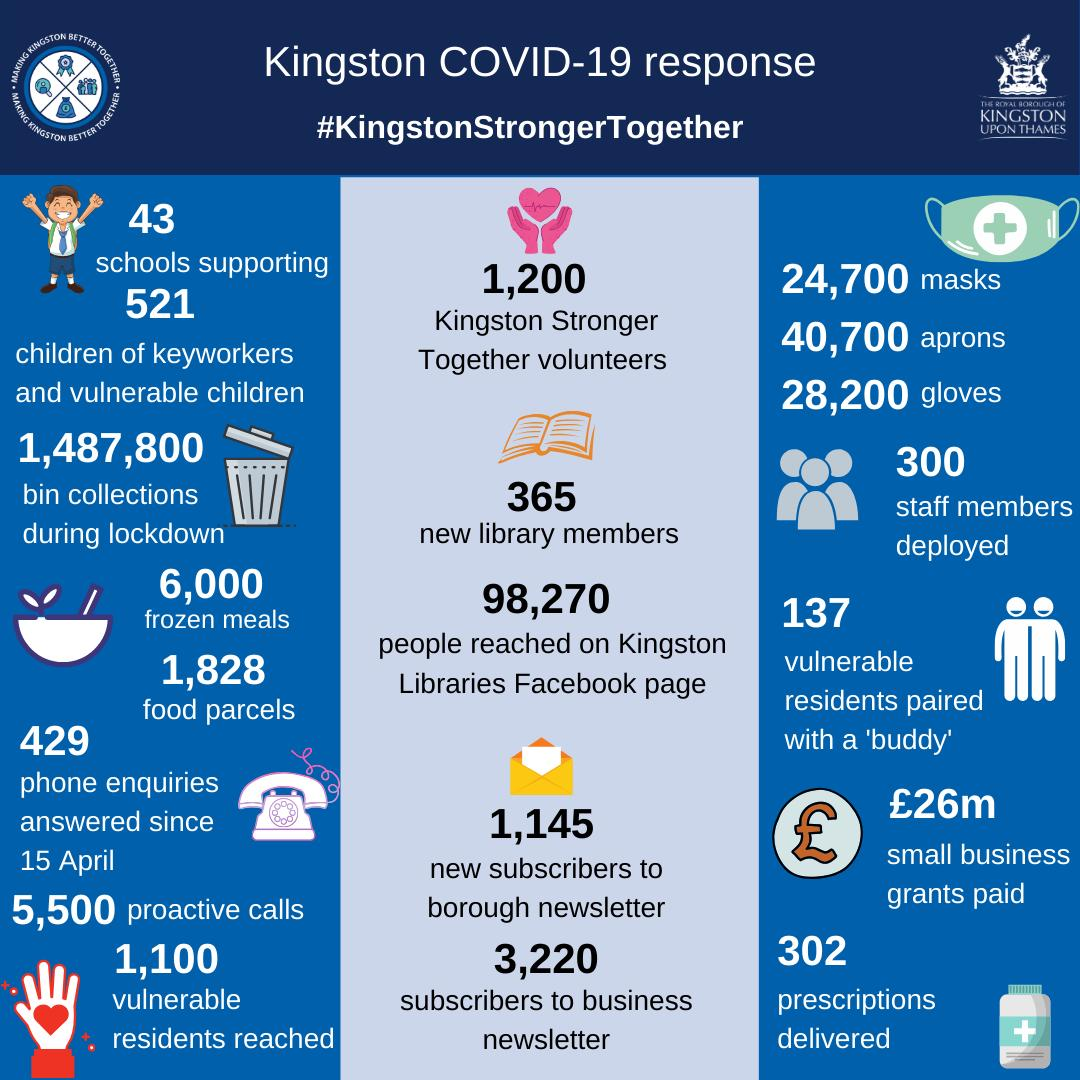Mention a couple of crucial points in this snapshot. Since April 15, a total of 429 phone enquiries have been answered. The number of subscribers to the business newsletter is approximately 3,220. 6000 frozen meals were provided. A total of 1,828 food parcels were delivered. There are approximately 1,200 Kingston Stronger Together volunteers. 